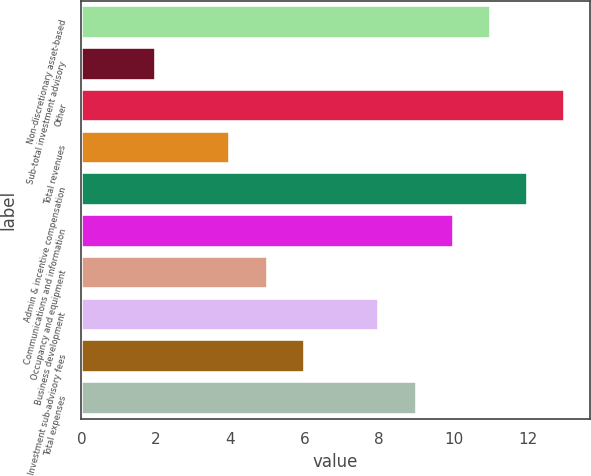Convert chart to OTSL. <chart><loc_0><loc_0><loc_500><loc_500><bar_chart><fcel>Non-discretionary asset-based<fcel>Sub-total investment advisory<fcel>Other<fcel>Total revenues<fcel>Admin & incentive compensation<fcel>Communications and information<fcel>Occupancy and equipment<fcel>Business development<fcel>Investment sub-advisory fees<fcel>Total expenses<nl><fcel>11<fcel>2<fcel>13<fcel>4<fcel>12<fcel>10<fcel>5<fcel>8<fcel>6<fcel>9<nl></chart> 